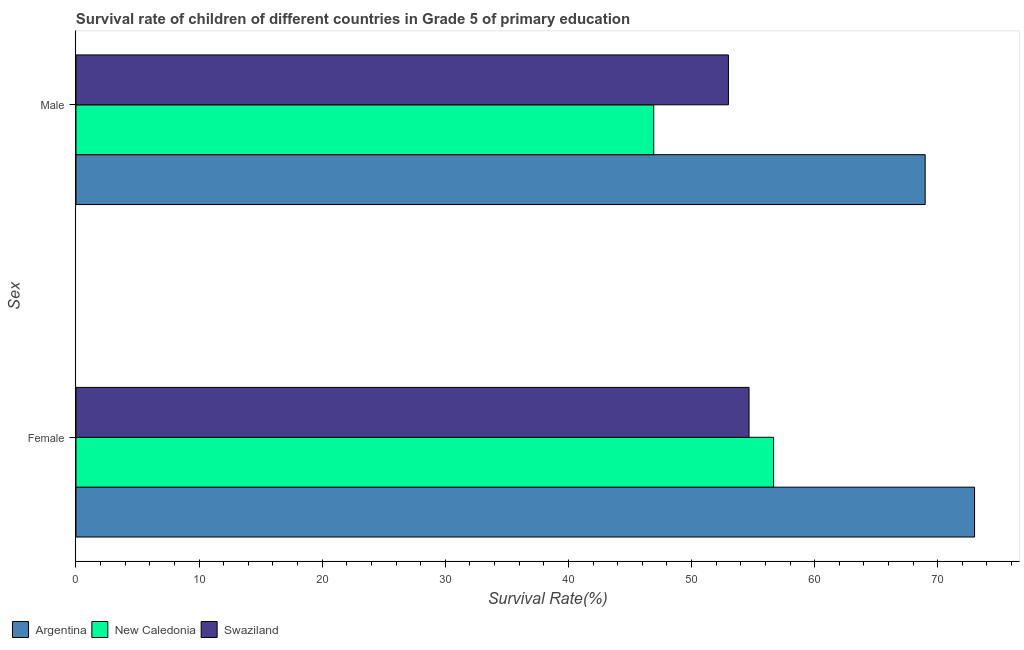How many groups of bars are there?
Provide a short and direct response. 2. Are the number of bars on each tick of the Y-axis equal?
Ensure brevity in your answer.  Yes. How many bars are there on the 2nd tick from the top?
Your answer should be very brief. 3. How many bars are there on the 1st tick from the bottom?
Provide a short and direct response. 3. What is the survival rate of female students in primary education in Argentina?
Your answer should be compact. 72.99. Across all countries, what is the maximum survival rate of male students in primary education?
Provide a short and direct response. 68.98. Across all countries, what is the minimum survival rate of male students in primary education?
Provide a short and direct response. 46.93. In which country was the survival rate of male students in primary education minimum?
Your response must be concise. New Caledonia. What is the total survival rate of male students in primary education in the graph?
Your answer should be very brief. 168.91. What is the difference between the survival rate of male students in primary education in Swaziland and that in New Caledonia?
Offer a very short reply. 6.07. What is the difference between the survival rate of male students in primary education in Swaziland and the survival rate of female students in primary education in New Caledonia?
Your answer should be compact. -3.67. What is the average survival rate of male students in primary education per country?
Your response must be concise. 56.3. What is the difference between the survival rate of male students in primary education and survival rate of female students in primary education in Swaziland?
Your response must be concise. -1.67. In how many countries, is the survival rate of male students in primary education greater than 50 %?
Your answer should be compact. 2. What is the ratio of the survival rate of male students in primary education in New Caledonia to that in Swaziland?
Offer a very short reply. 0.89. Is the survival rate of male students in primary education in Swaziland less than that in Argentina?
Offer a terse response. Yes. What does the 1st bar from the top in Male represents?
Your answer should be very brief. Swaziland. What does the 2nd bar from the bottom in Female represents?
Provide a succinct answer. New Caledonia. How many countries are there in the graph?
Make the answer very short. 3. How many legend labels are there?
Your answer should be very brief. 3. What is the title of the graph?
Your answer should be very brief. Survival rate of children of different countries in Grade 5 of primary education. What is the label or title of the X-axis?
Your answer should be very brief. Survival Rate(%). What is the label or title of the Y-axis?
Offer a terse response. Sex. What is the Survival Rate(%) in Argentina in Female?
Your answer should be very brief. 72.99. What is the Survival Rate(%) of New Caledonia in Female?
Provide a succinct answer. 56.67. What is the Survival Rate(%) in Swaziland in Female?
Offer a terse response. 54.67. What is the Survival Rate(%) in Argentina in Male?
Offer a terse response. 68.98. What is the Survival Rate(%) of New Caledonia in Male?
Ensure brevity in your answer.  46.93. What is the Survival Rate(%) in Swaziland in Male?
Offer a terse response. 53. Across all Sex, what is the maximum Survival Rate(%) of Argentina?
Make the answer very short. 72.99. Across all Sex, what is the maximum Survival Rate(%) of New Caledonia?
Keep it short and to the point. 56.67. Across all Sex, what is the maximum Survival Rate(%) in Swaziland?
Your answer should be compact. 54.67. Across all Sex, what is the minimum Survival Rate(%) in Argentina?
Make the answer very short. 68.98. Across all Sex, what is the minimum Survival Rate(%) in New Caledonia?
Provide a short and direct response. 46.93. Across all Sex, what is the minimum Survival Rate(%) of Swaziland?
Your answer should be very brief. 53. What is the total Survival Rate(%) in Argentina in the graph?
Offer a terse response. 141.97. What is the total Survival Rate(%) of New Caledonia in the graph?
Your response must be concise. 103.6. What is the total Survival Rate(%) in Swaziland in the graph?
Ensure brevity in your answer.  107.67. What is the difference between the Survival Rate(%) of Argentina in Female and that in Male?
Your response must be concise. 4.01. What is the difference between the Survival Rate(%) in New Caledonia in Female and that in Male?
Keep it short and to the point. 9.74. What is the difference between the Survival Rate(%) in Swaziland in Female and that in Male?
Keep it short and to the point. 1.67. What is the difference between the Survival Rate(%) of Argentina in Female and the Survival Rate(%) of New Caledonia in Male?
Provide a succinct answer. 26.06. What is the difference between the Survival Rate(%) in Argentina in Female and the Survival Rate(%) in Swaziland in Male?
Your answer should be very brief. 19.99. What is the difference between the Survival Rate(%) of New Caledonia in Female and the Survival Rate(%) of Swaziland in Male?
Provide a short and direct response. 3.67. What is the average Survival Rate(%) of Argentina per Sex?
Ensure brevity in your answer.  70.99. What is the average Survival Rate(%) of New Caledonia per Sex?
Your answer should be very brief. 51.8. What is the average Survival Rate(%) of Swaziland per Sex?
Provide a short and direct response. 53.84. What is the difference between the Survival Rate(%) in Argentina and Survival Rate(%) in New Caledonia in Female?
Your answer should be very brief. 16.32. What is the difference between the Survival Rate(%) of Argentina and Survival Rate(%) of Swaziland in Female?
Offer a very short reply. 18.32. What is the difference between the Survival Rate(%) in New Caledonia and Survival Rate(%) in Swaziland in Female?
Offer a terse response. 1.99. What is the difference between the Survival Rate(%) in Argentina and Survival Rate(%) in New Caledonia in Male?
Your answer should be compact. 22.05. What is the difference between the Survival Rate(%) in Argentina and Survival Rate(%) in Swaziland in Male?
Offer a terse response. 15.98. What is the difference between the Survival Rate(%) in New Caledonia and Survival Rate(%) in Swaziland in Male?
Keep it short and to the point. -6.07. What is the ratio of the Survival Rate(%) of Argentina in Female to that in Male?
Your answer should be very brief. 1.06. What is the ratio of the Survival Rate(%) in New Caledonia in Female to that in Male?
Provide a succinct answer. 1.21. What is the ratio of the Survival Rate(%) in Swaziland in Female to that in Male?
Give a very brief answer. 1.03. What is the difference between the highest and the second highest Survival Rate(%) of Argentina?
Provide a succinct answer. 4.01. What is the difference between the highest and the second highest Survival Rate(%) of New Caledonia?
Provide a short and direct response. 9.74. What is the difference between the highest and the second highest Survival Rate(%) in Swaziland?
Make the answer very short. 1.67. What is the difference between the highest and the lowest Survival Rate(%) of Argentina?
Offer a terse response. 4.01. What is the difference between the highest and the lowest Survival Rate(%) in New Caledonia?
Keep it short and to the point. 9.74. What is the difference between the highest and the lowest Survival Rate(%) of Swaziland?
Provide a short and direct response. 1.67. 